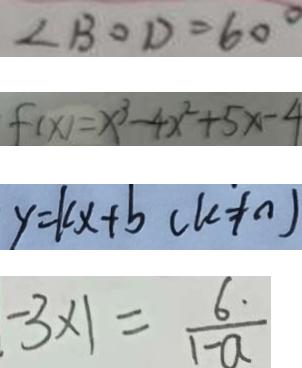Convert formula to latex. <formula><loc_0><loc_0><loc_500><loc_500>\angle B O D = 6 0 ^ { \circ } 
 f ( x ) = x ^ { 3 } - 4 x ^ { 2 } + 5 x - 4 
 y = k x + b ( k \neq 0 ) 
 - 3 \times 1 = \frac { 6 \cdot } { 1 - a }</formula> 